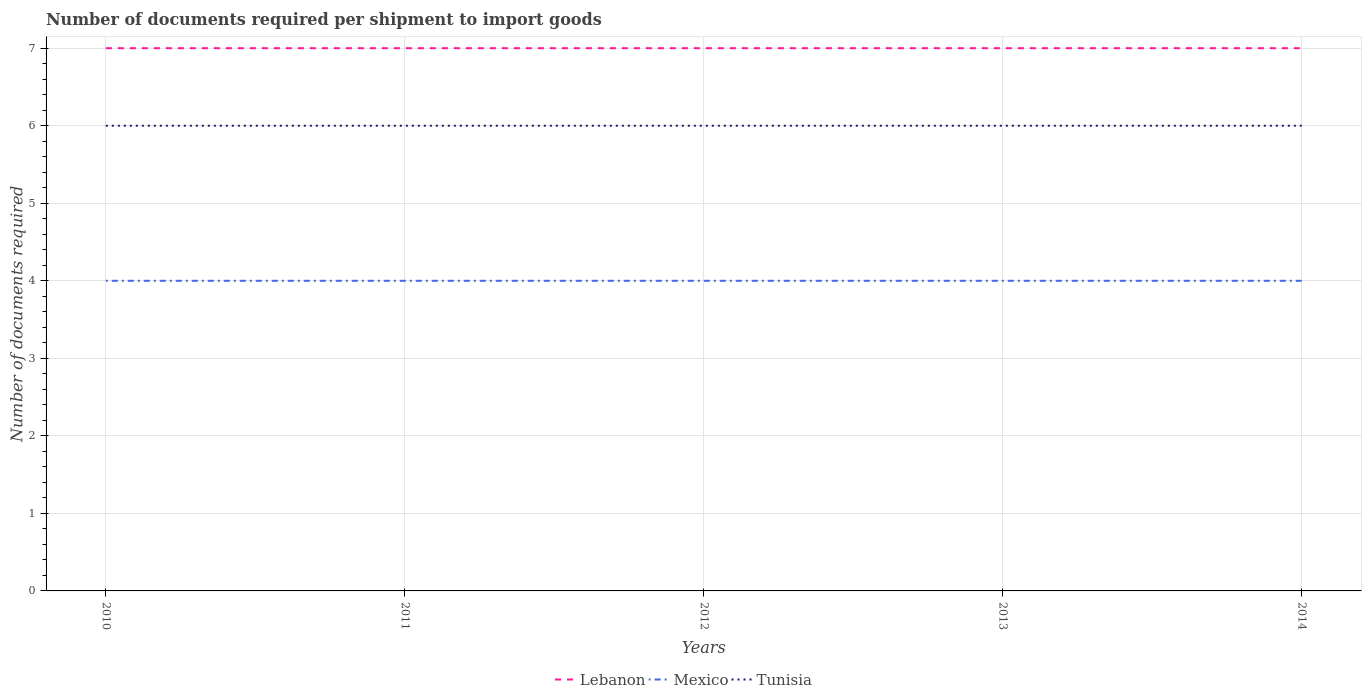Is the number of lines equal to the number of legend labels?
Give a very brief answer. Yes. In which year was the number of documents required per shipment to import goods in Lebanon maximum?
Provide a succinct answer. 2010. What is the total number of documents required per shipment to import goods in Tunisia in the graph?
Provide a short and direct response. 0. How many lines are there?
Provide a succinct answer. 3. How many years are there in the graph?
Make the answer very short. 5. What is the difference between two consecutive major ticks on the Y-axis?
Offer a terse response. 1. Are the values on the major ticks of Y-axis written in scientific E-notation?
Give a very brief answer. No. Does the graph contain grids?
Provide a short and direct response. Yes. How many legend labels are there?
Offer a terse response. 3. What is the title of the graph?
Your answer should be compact. Number of documents required per shipment to import goods. What is the label or title of the X-axis?
Provide a short and direct response. Years. What is the label or title of the Y-axis?
Your answer should be compact. Number of documents required. What is the Number of documents required in Lebanon in 2010?
Make the answer very short. 7. What is the Number of documents required in Tunisia in 2010?
Offer a terse response. 6. What is the Number of documents required of Lebanon in 2011?
Your response must be concise. 7. What is the Number of documents required in Mexico in 2011?
Give a very brief answer. 4. What is the Number of documents required of Tunisia in 2012?
Make the answer very short. 6. What is the Number of documents required in Mexico in 2013?
Make the answer very short. 4. What is the Number of documents required of Lebanon in 2014?
Provide a short and direct response. 7. What is the Number of documents required in Mexico in 2014?
Offer a terse response. 4. Across all years, what is the maximum Number of documents required of Lebanon?
Give a very brief answer. 7. Across all years, what is the maximum Number of documents required of Tunisia?
Keep it short and to the point. 6. Across all years, what is the minimum Number of documents required of Lebanon?
Make the answer very short. 7. Across all years, what is the minimum Number of documents required in Mexico?
Make the answer very short. 4. What is the total Number of documents required in Lebanon in the graph?
Provide a succinct answer. 35. What is the difference between the Number of documents required in Lebanon in 2010 and that in 2011?
Your answer should be very brief. 0. What is the difference between the Number of documents required in Mexico in 2010 and that in 2011?
Your answer should be compact. 0. What is the difference between the Number of documents required of Lebanon in 2010 and that in 2012?
Your answer should be compact. 0. What is the difference between the Number of documents required of Lebanon in 2010 and that in 2013?
Your answer should be compact. 0. What is the difference between the Number of documents required of Mexico in 2010 and that in 2013?
Keep it short and to the point. 0. What is the difference between the Number of documents required of Tunisia in 2010 and that in 2013?
Give a very brief answer. 0. What is the difference between the Number of documents required in Mexico in 2011 and that in 2012?
Give a very brief answer. 0. What is the difference between the Number of documents required in Lebanon in 2011 and that in 2013?
Make the answer very short. 0. What is the difference between the Number of documents required in Lebanon in 2011 and that in 2014?
Provide a short and direct response. 0. What is the difference between the Number of documents required of Mexico in 2012 and that in 2013?
Offer a terse response. 0. What is the difference between the Number of documents required of Mexico in 2012 and that in 2014?
Offer a very short reply. 0. What is the difference between the Number of documents required in Lebanon in 2013 and that in 2014?
Your answer should be very brief. 0. What is the difference between the Number of documents required in Lebanon in 2010 and the Number of documents required in Tunisia in 2011?
Your answer should be very brief. 1. What is the difference between the Number of documents required of Mexico in 2010 and the Number of documents required of Tunisia in 2011?
Offer a very short reply. -2. What is the difference between the Number of documents required of Lebanon in 2010 and the Number of documents required of Tunisia in 2012?
Ensure brevity in your answer.  1. What is the difference between the Number of documents required in Mexico in 2010 and the Number of documents required in Tunisia in 2013?
Your response must be concise. -2. What is the difference between the Number of documents required in Lebanon in 2010 and the Number of documents required in Mexico in 2014?
Provide a succinct answer. 3. What is the difference between the Number of documents required of Mexico in 2010 and the Number of documents required of Tunisia in 2014?
Provide a short and direct response. -2. What is the difference between the Number of documents required of Lebanon in 2011 and the Number of documents required of Tunisia in 2013?
Your response must be concise. 1. What is the difference between the Number of documents required of Lebanon in 2011 and the Number of documents required of Mexico in 2014?
Your response must be concise. 3. What is the difference between the Number of documents required in Lebanon in 2011 and the Number of documents required in Tunisia in 2014?
Provide a short and direct response. 1. What is the difference between the Number of documents required of Mexico in 2011 and the Number of documents required of Tunisia in 2014?
Offer a terse response. -2. What is the difference between the Number of documents required in Lebanon in 2012 and the Number of documents required in Tunisia in 2013?
Give a very brief answer. 1. What is the difference between the Number of documents required of Lebanon in 2012 and the Number of documents required of Mexico in 2014?
Your response must be concise. 3. What is the difference between the Number of documents required of Lebanon in 2012 and the Number of documents required of Tunisia in 2014?
Provide a succinct answer. 1. What is the difference between the Number of documents required of Mexico in 2012 and the Number of documents required of Tunisia in 2014?
Provide a succinct answer. -2. What is the difference between the Number of documents required in Lebanon in 2013 and the Number of documents required in Mexico in 2014?
Offer a very short reply. 3. What is the average Number of documents required in Lebanon per year?
Ensure brevity in your answer.  7. What is the average Number of documents required in Mexico per year?
Keep it short and to the point. 4. What is the average Number of documents required of Tunisia per year?
Your response must be concise. 6. In the year 2010, what is the difference between the Number of documents required in Mexico and Number of documents required in Tunisia?
Make the answer very short. -2. In the year 2011, what is the difference between the Number of documents required in Mexico and Number of documents required in Tunisia?
Keep it short and to the point. -2. In the year 2013, what is the difference between the Number of documents required in Lebanon and Number of documents required in Tunisia?
Offer a terse response. 1. In the year 2013, what is the difference between the Number of documents required of Mexico and Number of documents required of Tunisia?
Offer a terse response. -2. What is the ratio of the Number of documents required in Lebanon in 2010 to that in 2012?
Ensure brevity in your answer.  1. What is the ratio of the Number of documents required in Mexico in 2010 to that in 2012?
Keep it short and to the point. 1. What is the ratio of the Number of documents required of Lebanon in 2010 to that in 2013?
Offer a terse response. 1. What is the ratio of the Number of documents required in Mexico in 2010 to that in 2013?
Keep it short and to the point. 1. What is the ratio of the Number of documents required in Mexico in 2010 to that in 2014?
Offer a very short reply. 1. What is the ratio of the Number of documents required in Mexico in 2011 to that in 2012?
Keep it short and to the point. 1. What is the ratio of the Number of documents required in Tunisia in 2011 to that in 2013?
Provide a succinct answer. 1. What is the ratio of the Number of documents required in Lebanon in 2011 to that in 2014?
Your answer should be very brief. 1. What is the ratio of the Number of documents required of Mexico in 2011 to that in 2014?
Offer a terse response. 1. What is the ratio of the Number of documents required of Lebanon in 2012 to that in 2013?
Your answer should be very brief. 1. What is the ratio of the Number of documents required in Mexico in 2012 to that in 2013?
Provide a short and direct response. 1. What is the ratio of the Number of documents required of Mexico in 2012 to that in 2014?
Give a very brief answer. 1. What is the ratio of the Number of documents required in Lebanon in 2013 to that in 2014?
Ensure brevity in your answer.  1. What is the ratio of the Number of documents required of Mexico in 2013 to that in 2014?
Offer a terse response. 1. What is the difference between the highest and the second highest Number of documents required of Lebanon?
Offer a terse response. 0. What is the difference between the highest and the second highest Number of documents required in Mexico?
Your answer should be very brief. 0. What is the difference between the highest and the second highest Number of documents required in Tunisia?
Ensure brevity in your answer.  0. What is the difference between the highest and the lowest Number of documents required of Tunisia?
Your answer should be compact. 0. 